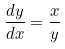<formula> <loc_0><loc_0><loc_500><loc_500>\frac { d y } { d x } = \frac { x } { y }</formula> 